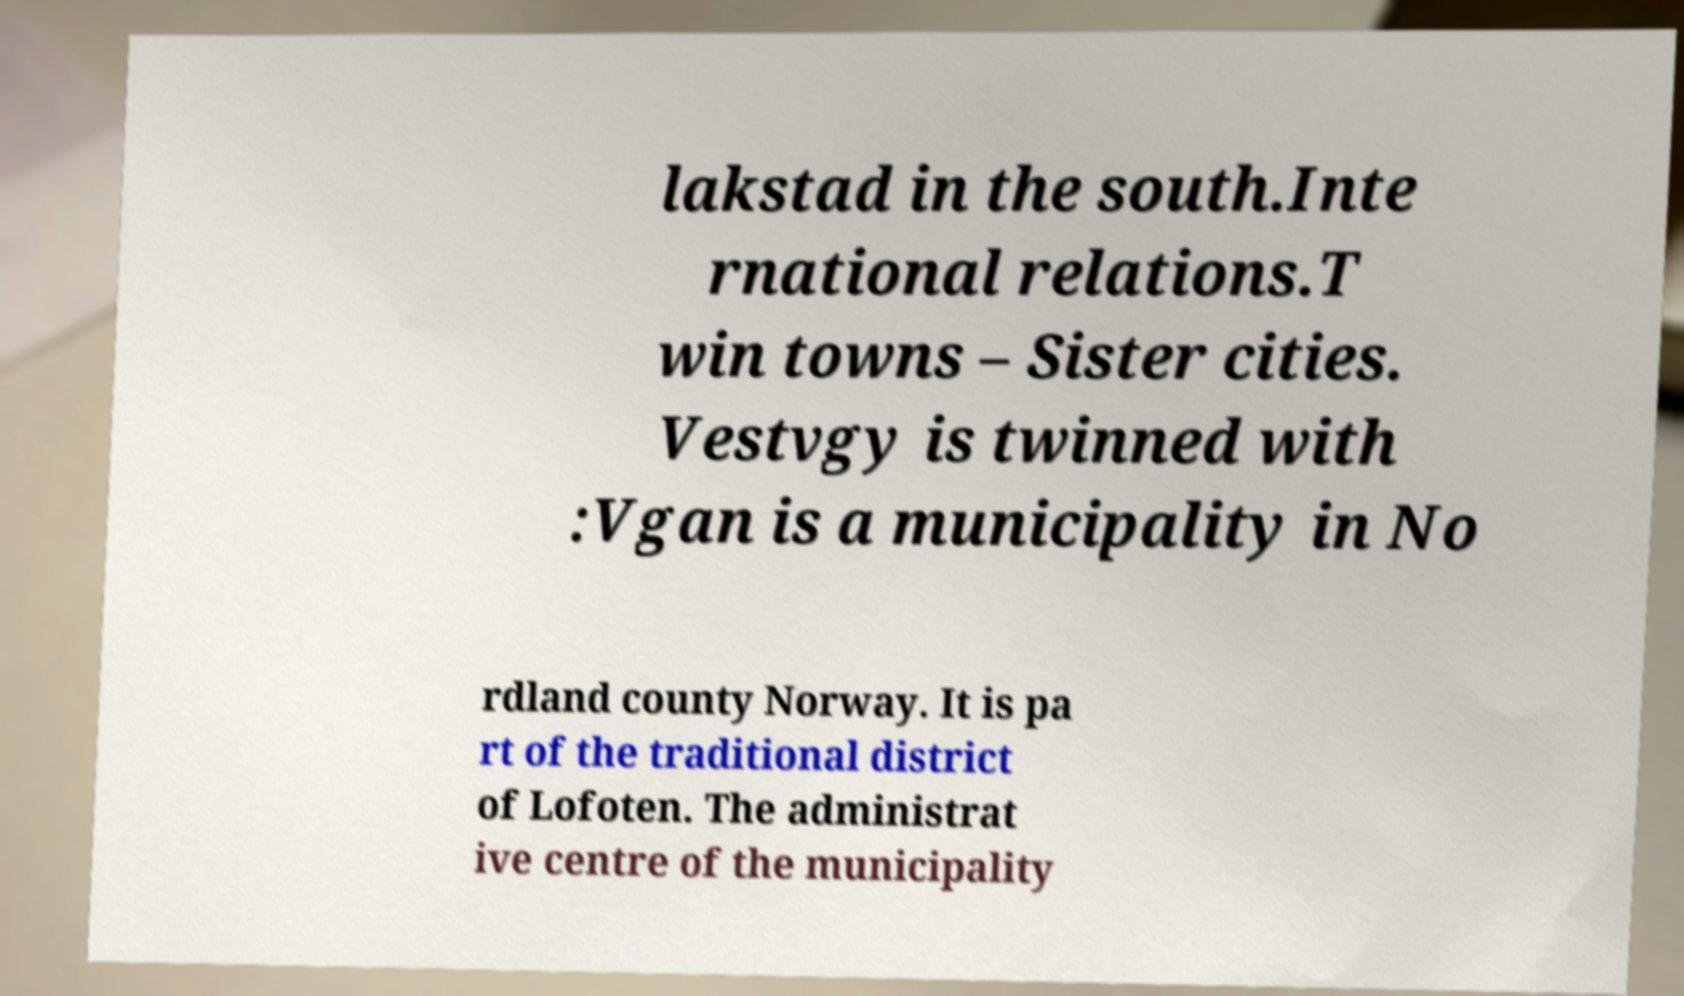Please identify and transcribe the text found in this image. lakstad in the south.Inte rnational relations.T win towns – Sister cities. Vestvgy is twinned with :Vgan is a municipality in No rdland county Norway. It is pa rt of the traditional district of Lofoten. The administrat ive centre of the municipality 